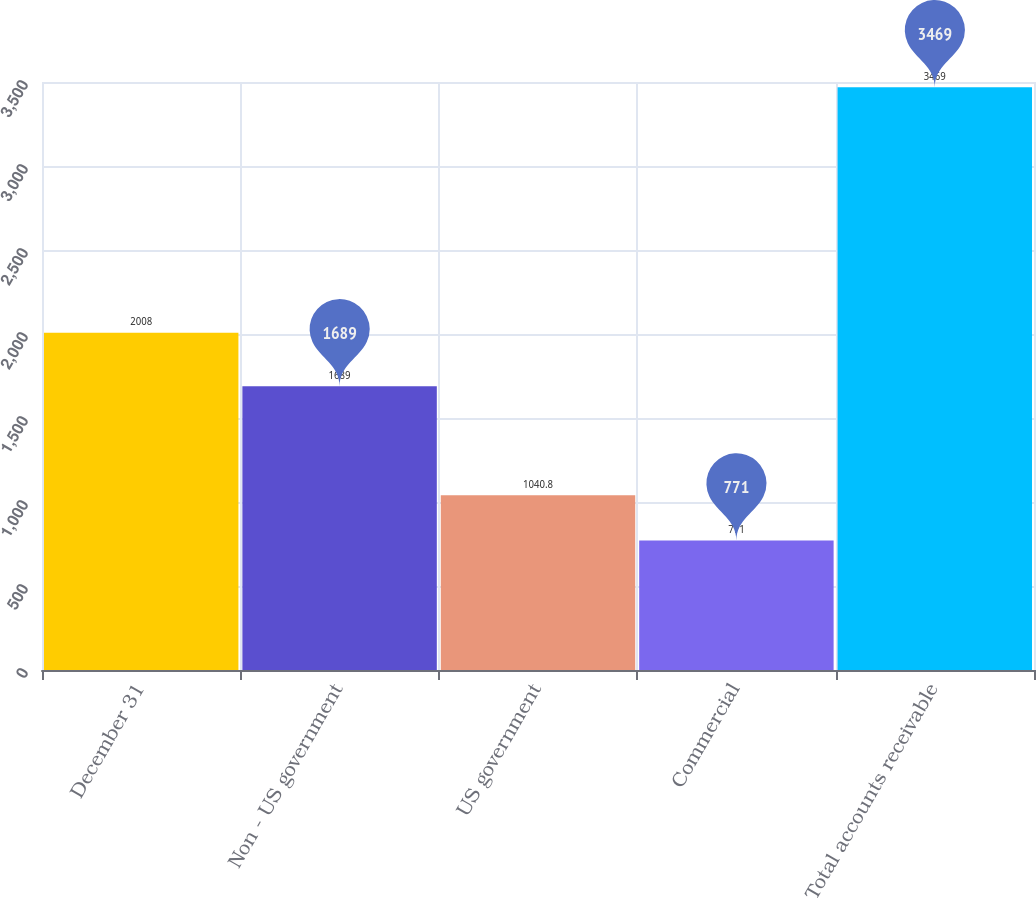<chart> <loc_0><loc_0><loc_500><loc_500><bar_chart><fcel>December 31<fcel>Non - US government<fcel>US government<fcel>Commercial<fcel>Total accounts receivable<nl><fcel>2008<fcel>1689<fcel>1040.8<fcel>771<fcel>3469<nl></chart> 